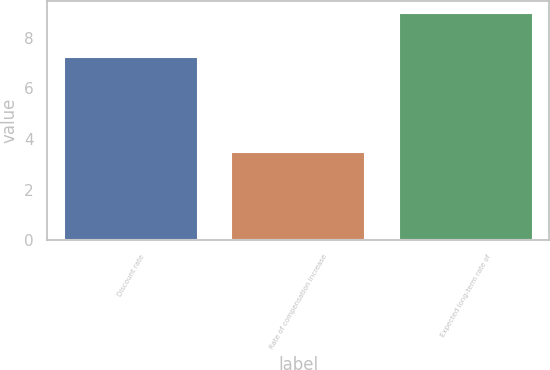<chart> <loc_0><loc_0><loc_500><loc_500><bar_chart><fcel>Discount rate<fcel>Rate of compensation increase<fcel>Expected long-term rate of<nl><fcel>7.25<fcel>3.5<fcel>9<nl></chart> 